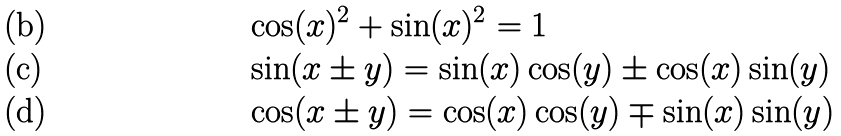<formula> <loc_0><loc_0><loc_500><loc_500>& \cos ( x ) ^ { 2 } + \sin ( x ) ^ { 2 } = 1 \\ & \sin ( x \pm y ) = \sin ( x ) \cos ( y ) \pm \cos ( x ) \sin ( y ) \\ & \cos ( x \pm y ) = \cos ( x ) \cos ( y ) \mp \sin ( x ) \sin ( y )</formula> 